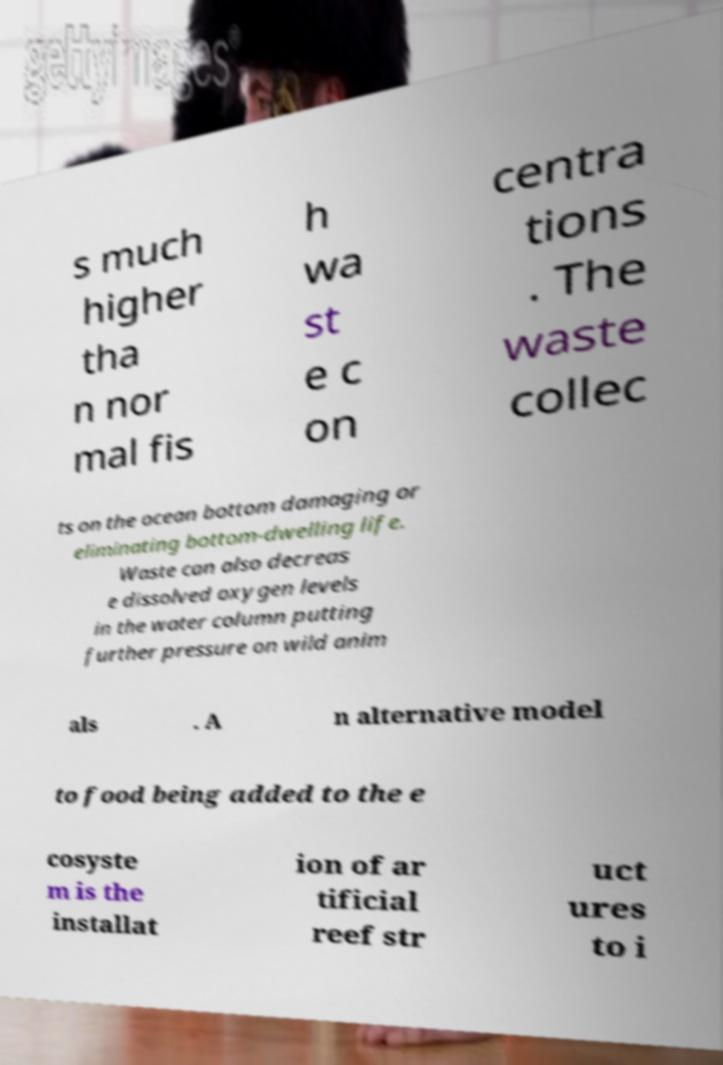Please identify and transcribe the text found in this image. s much higher tha n nor mal fis h wa st e c on centra tions . The waste collec ts on the ocean bottom damaging or eliminating bottom-dwelling life. Waste can also decreas e dissolved oxygen levels in the water column putting further pressure on wild anim als . A n alternative model to food being added to the e cosyste m is the installat ion of ar tificial reef str uct ures to i 